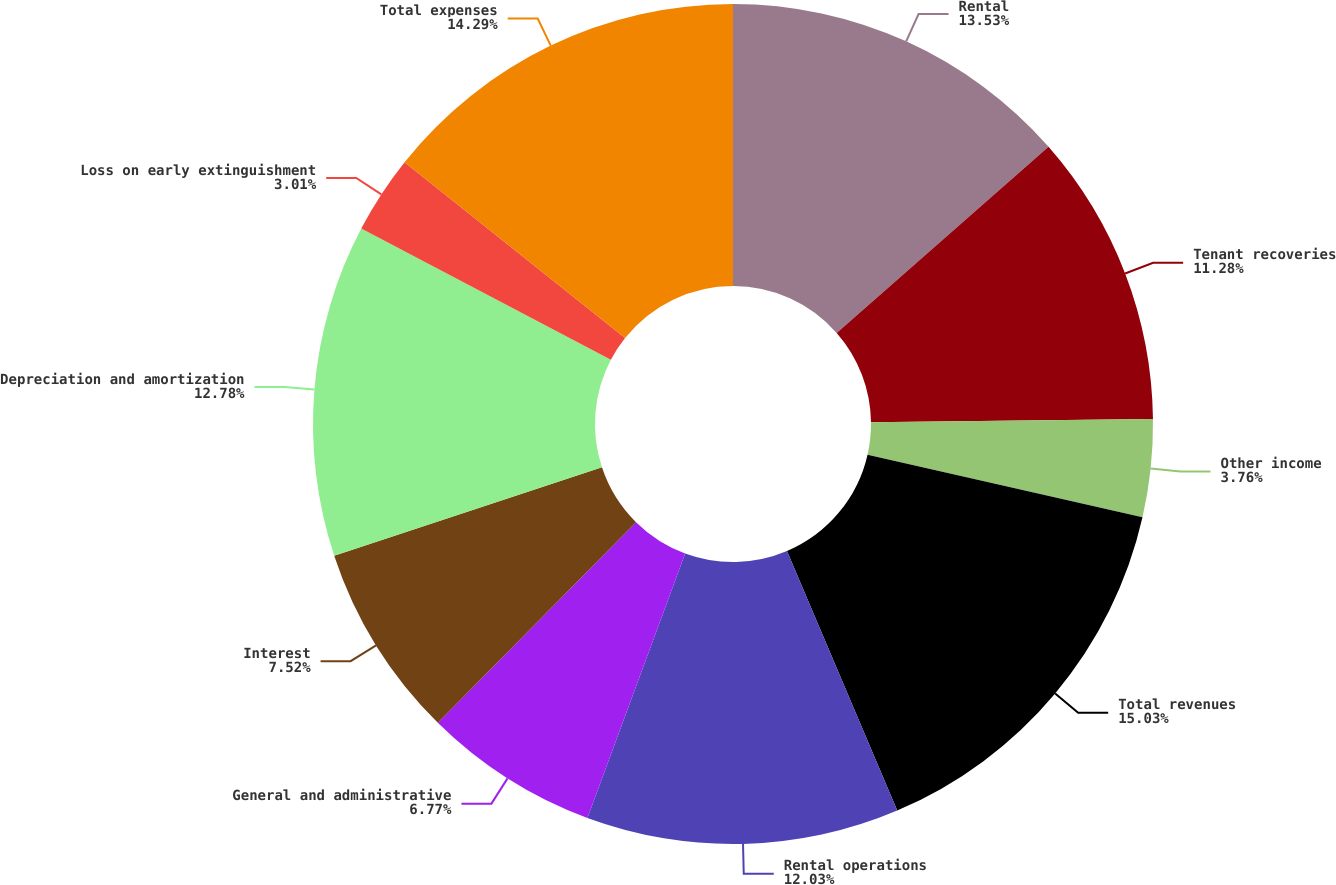Convert chart. <chart><loc_0><loc_0><loc_500><loc_500><pie_chart><fcel>Rental<fcel>Tenant recoveries<fcel>Other income<fcel>Total revenues<fcel>Rental operations<fcel>General and administrative<fcel>Interest<fcel>Depreciation and amortization<fcel>Loss on early extinguishment<fcel>Total expenses<nl><fcel>13.53%<fcel>11.28%<fcel>3.76%<fcel>15.04%<fcel>12.03%<fcel>6.77%<fcel>7.52%<fcel>12.78%<fcel>3.01%<fcel>14.29%<nl></chart> 